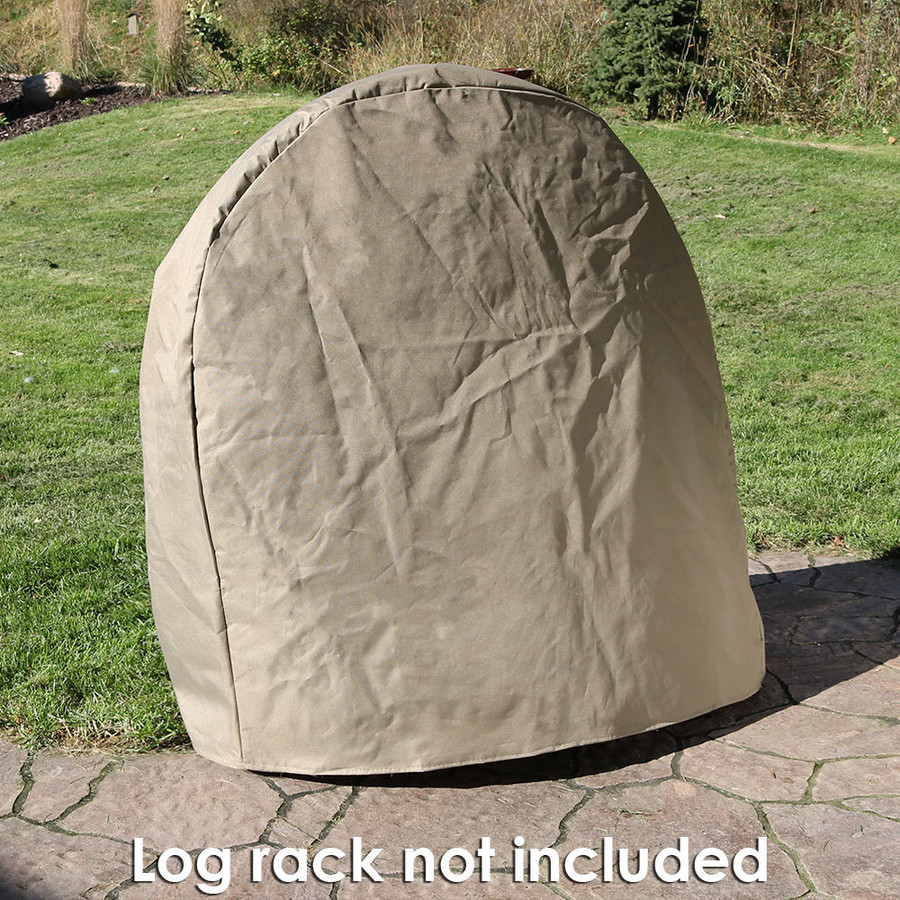Are there any signs indicating the maintenance of this area? The grass area surrounding the cover appears well-maintained, suggesting regular landscaping. The neatness of the lawn and the lack of substantial weed growth or debris accumulate over a well-cared-for outdoor space. This upkeep might include mowing, trimming, and possibly the application of lawn care treatments to maintain its lush, green appearance. 